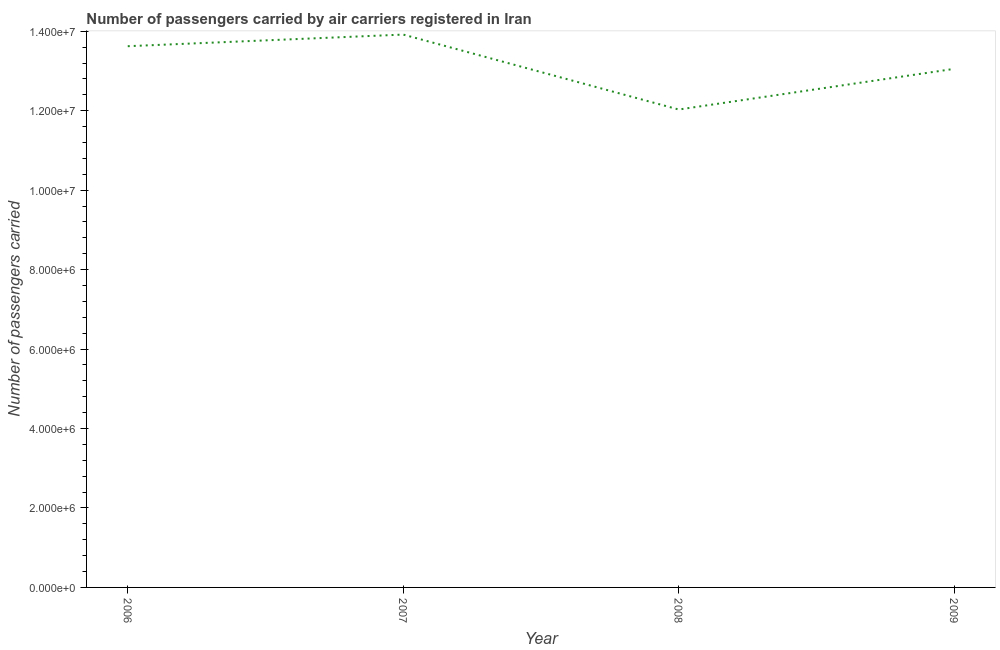What is the number of passengers carried in 2009?
Provide a short and direct response. 1.31e+07. Across all years, what is the maximum number of passengers carried?
Provide a succinct answer. 1.39e+07. Across all years, what is the minimum number of passengers carried?
Give a very brief answer. 1.20e+07. What is the sum of the number of passengers carried?
Ensure brevity in your answer.  5.26e+07. What is the difference between the number of passengers carried in 2007 and 2009?
Provide a short and direct response. 8.63e+05. What is the average number of passengers carried per year?
Your answer should be compact. 1.32e+07. What is the median number of passengers carried?
Give a very brief answer. 1.33e+07. Do a majority of the years between 2009 and 2007 (inclusive) have number of passengers carried greater than 8000000 ?
Keep it short and to the point. No. What is the ratio of the number of passengers carried in 2006 to that in 2007?
Give a very brief answer. 0.98. What is the difference between the highest and the second highest number of passengers carried?
Provide a succinct answer. 2.93e+05. Is the sum of the number of passengers carried in 2008 and 2009 greater than the maximum number of passengers carried across all years?
Offer a terse response. Yes. What is the difference between the highest and the lowest number of passengers carried?
Make the answer very short. 1.89e+06. In how many years, is the number of passengers carried greater than the average number of passengers carried taken over all years?
Your answer should be compact. 2. How many lines are there?
Your answer should be very brief. 1. What is the difference between two consecutive major ticks on the Y-axis?
Your response must be concise. 2.00e+06. Does the graph contain any zero values?
Offer a very short reply. No. Does the graph contain grids?
Provide a succinct answer. No. What is the title of the graph?
Make the answer very short. Number of passengers carried by air carriers registered in Iran. What is the label or title of the Y-axis?
Your answer should be very brief. Number of passengers carried. What is the Number of passengers carried of 2006?
Your response must be concise. 1.36e+07. What is the Number of passengers carried of 2007?
Make the answer very short. 1.39e+07. What is the Number of passengers carried in 2008?
Your answer should be very brief. 1.20e+07. What is the Number of passengers carried of 2009?
Offer a terse response. 1.31e+07. What is the difference between the Number of passengers carried in 2006 and 2007?
Offer a very short reply. -2.93e+05. What is the difference between the Number of passengers carried in 2006 and 2008?
Your answer should be very brief. 1.59e+06. What is the difference between the Number of passengers carried in 2006 and 2009?
Give a very brief answer. 5.70e+05. What is the difference between the Number of passengers carried in 2007 and 2008?
Make the answer very short. 1.89e+06. What is the difference between the Number of passengers carried in 2007 and 2009?
Provide a short and direct response. 8.63e+05. What is the difference between the Number of passengers carried in 2008 and 2009?
Offer a very short reply. -1.02e+06. What is the ratio of the Number of passengers carried in 2006 to that in 2007?
Your response must be concise. 0.98. What is the ratio of the Number of passengers carried in 2006 to that in 2008?
Your response must be concise. 1.13. What is the ratio of the Number of passengers carried in 2006 to that in 2009?
Your answer should be compact. 1.04. What is the ratio of the Number of passengers carried in 2007 to that in 2008?
Provide a short and direct response. 1.16. What is the ratio of the Number of passengers carried in 2007 to that in 2009?
Offer a terse response. 1.07. What is the ratio of the Number of passengers carried in 2008 to that in 2009?
Provide a succinct answer. 0.92. 